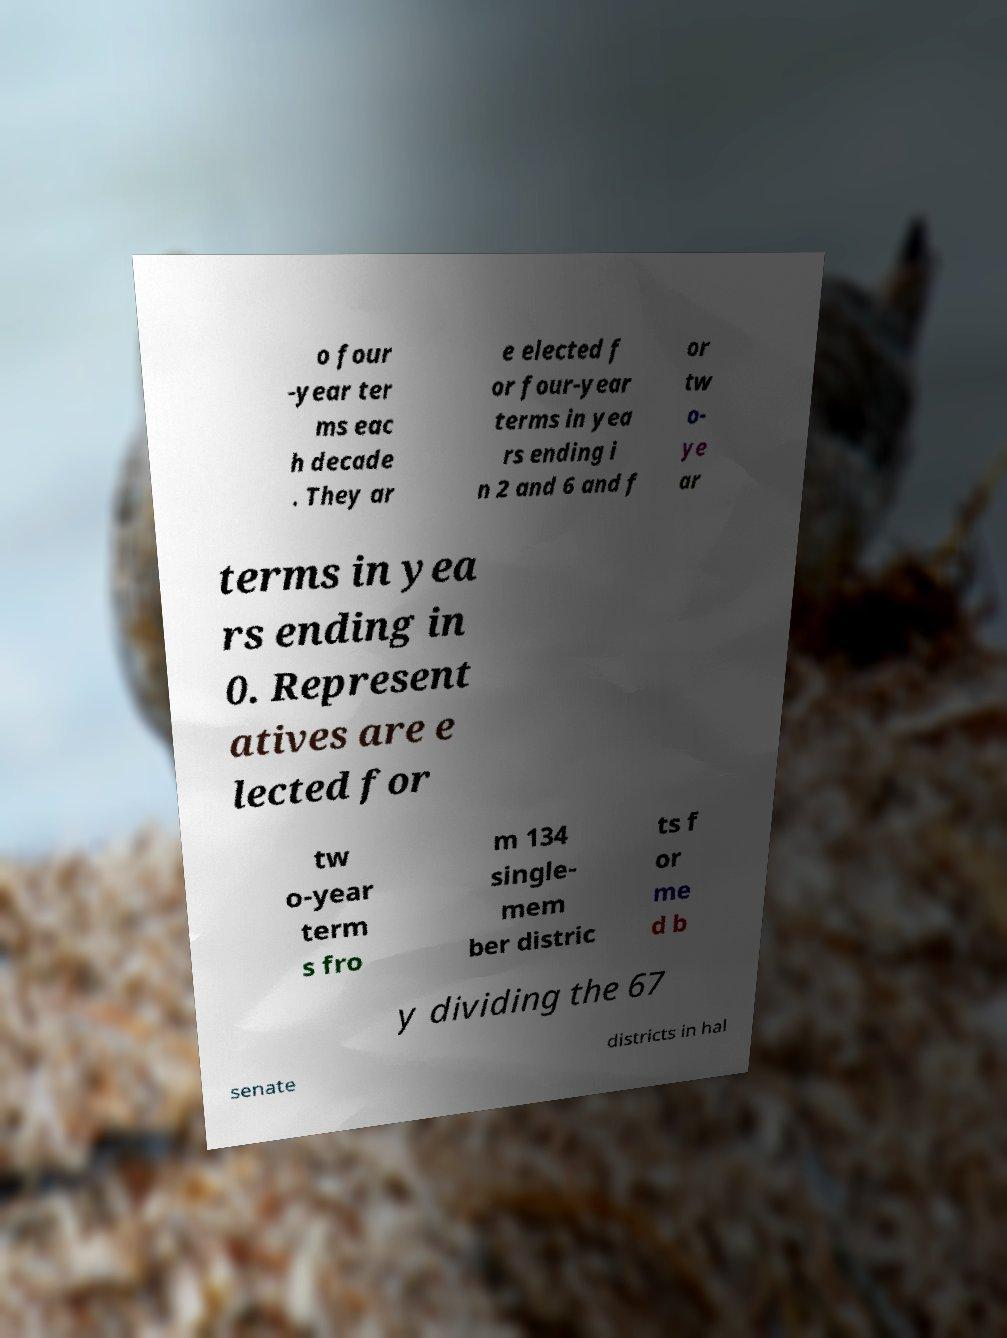What messages or text are displayed in this image? I need them in a readable, typed format. o four -year ter ms eac h decade . They ar e elected f or four-year terms in yea rs ending i n 2 and 6 and f or tw o- ye ar terms in yea rs ending in 0. Represent atives are e lected for tw o-year term s fro m 134 single- mem ber distric ts f or me d b y dividing the 67 senate districts in hal 